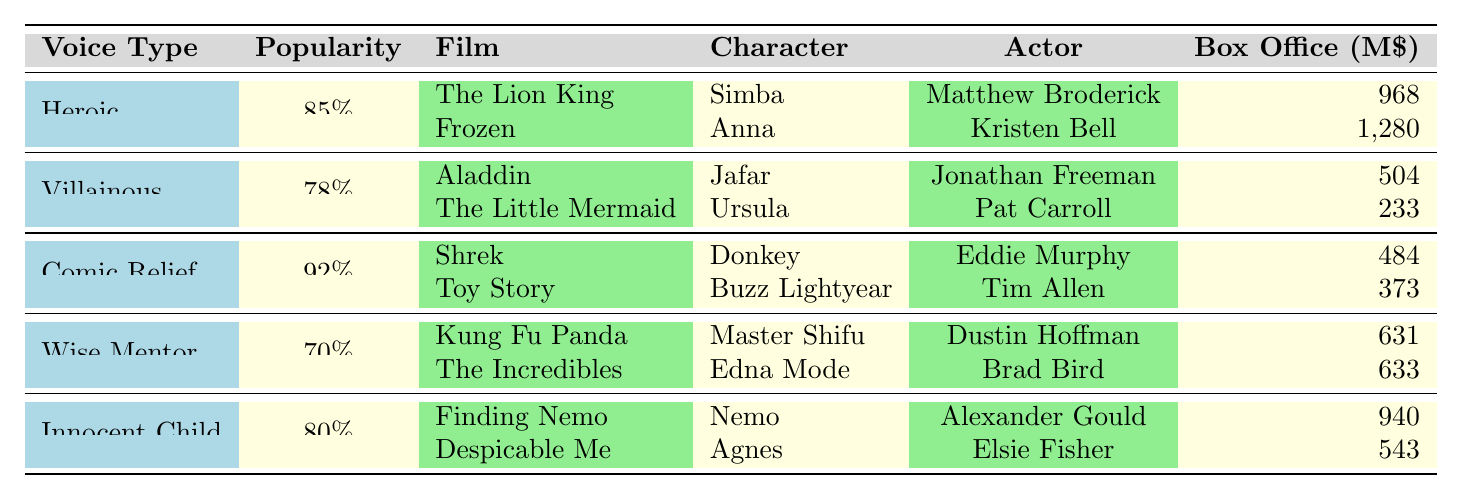What is the most popular character voice type? The table shows the popularity percentages for each voice type. The Comic Relief type has the highest popularity at 92%.
Answer: Comic Relief Which character from a Heroic voice type has the highest box office? Under Heroic voice type, the characters are Simba from The Lion King with $968 million and Anna from Frozen with $1,280 million. Anna has the highest box office.
Answer: Anna Is the box office of the villain Jafar higher than the villain Ursula? The table lists Jafar's box office at $504 million and Ursula's at $233 million. Since $504 million is more than $233 million, Jafar's box office is higher.
Answer: Yes What is the average popularity of the Wise Mentor and Innocent Child voice types? The popularity for Wise Mentor is 70% and for Innocent Child is 80%. The average is (70 + 80) / 2 = 75%.
Answer: 75% Which film in the Comic Relief voice type features a character voiced by Tim Allen? In the Comic Relief category, Buzz Lightyear from Toy Story is voiced by Tim Allen.
Answer: Toy Story Which voice type has a lower average box office, Heroic or Wise Mentor? The Heroic characters have box office earnings of $968 million (Simba) and $1,280 million (Anna), averaging ($968 + 1280) / 2 = $1,124 million. The Wise Mentor characters have $631 million (Master Shifu) and $633 million (Edna Mode), averaging ($631 + 633) / 2 = $632 million. Since $632 million is less than $1,124 million, Wise Mentor has a lower average.
Answer: Wise Mentor What is the total box office for all characters in the Innocent Child type? The Innocent Child characters are Nemo with $940 million and Agnes with $543 million. The total box office is $940 + 543 = $1,483 million.
Answer: $1,483 million Are there any characters in the table that have a box office above $1 billion? The only character with a box office over $1 billion is Anna from Frozen, who has $1,280 million.
Answer: Yes How many total character examples are listed in the Villainous voice type? There are two characters listed under Villainous: Jafar and Ursula. Thus, the total is 2.
Answer: 2 